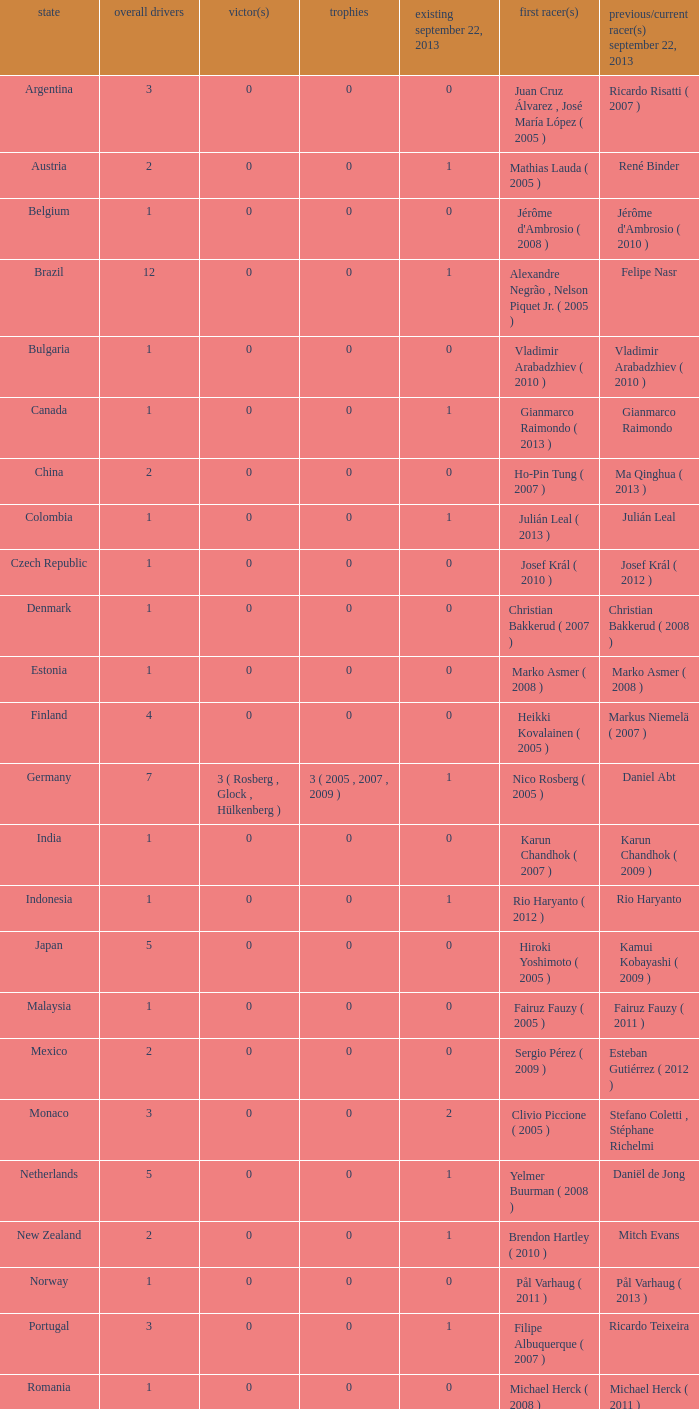How many champions were there when the last driver for September 22, 2013 was vladimir arabadzhiev ( 2010 )? 0.0. 